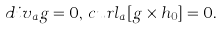Convert formula to latex. <formula><loc_0><loc_0><loc_500><loc_500>d i v _ { a } { g } = 0 , \, c u r l _ { a } [ { g \times h _ { 0 } } ] = 0 .</formula> 